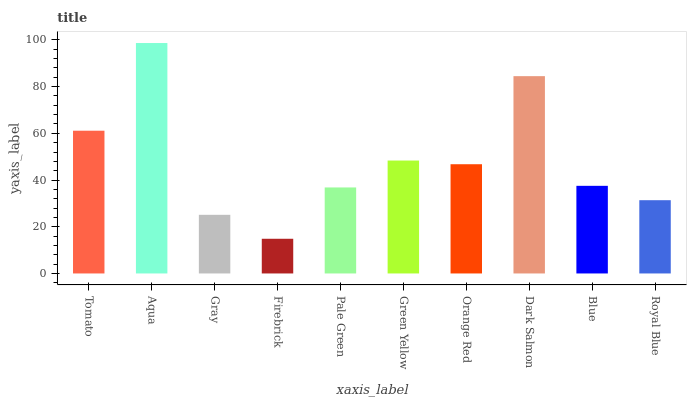Is Firebrick the minimum?
Answer yes or no. Yes. Is Aqua the maximum?
Answer yes or no. Yes. Is Gray the minimum?
Answer yes or no. No. Is Gray the maximum?
Answer yes or no. No. Is Aqua greater than Gray?
Answer yes or no. Yes. Is Gray less than Aqua?
Answer yes or no. Yes. Is Gray greater than Aqua?
Answer yes or no. No. Is Aqua less than Gray?
Answer yes or no. No. Is Orange Red the high median?
Answer yes or no. Yes. Is Blue the low median?
Answer yes or no. Yes. Is Tomato the high median?
Answer yes or no. No. Is Gray the low median?
Answer yes or no. No. 